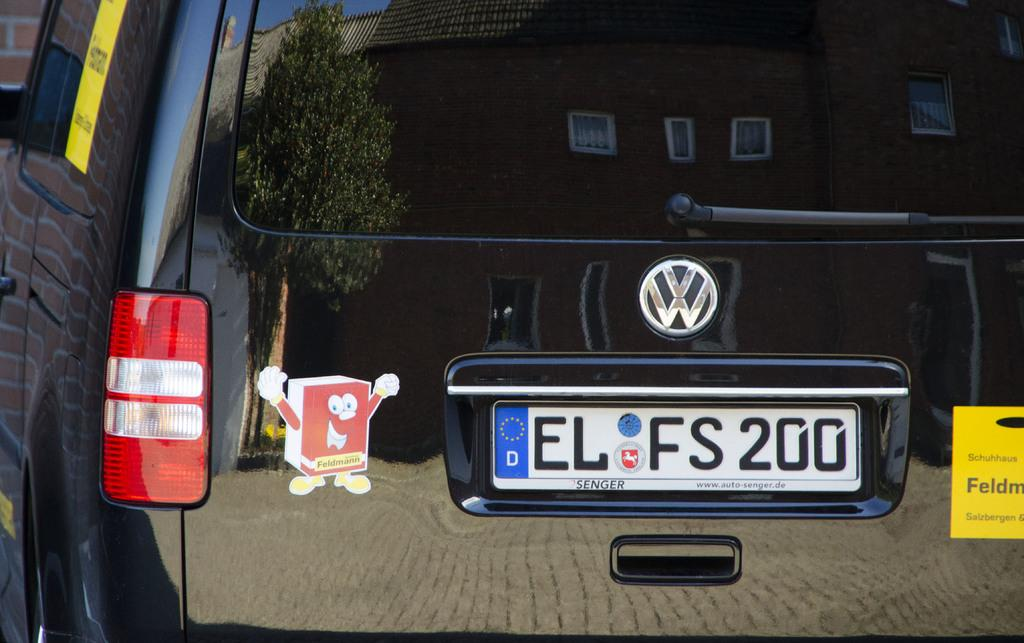<image>
Create a compact narrative representing the image presented. A VW vehicle has a license plate that reads ELFS200. 